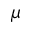Convert formula to latex. <formula><loc_0><loc_0><loc_500><loc_500>\mu</formula> 